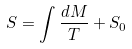Convert formula to latex. <formula><loc_0><loc_0><loc_500><loc_500>S = \int \frac { d M } { T } + S _ { 0 }</formula> 